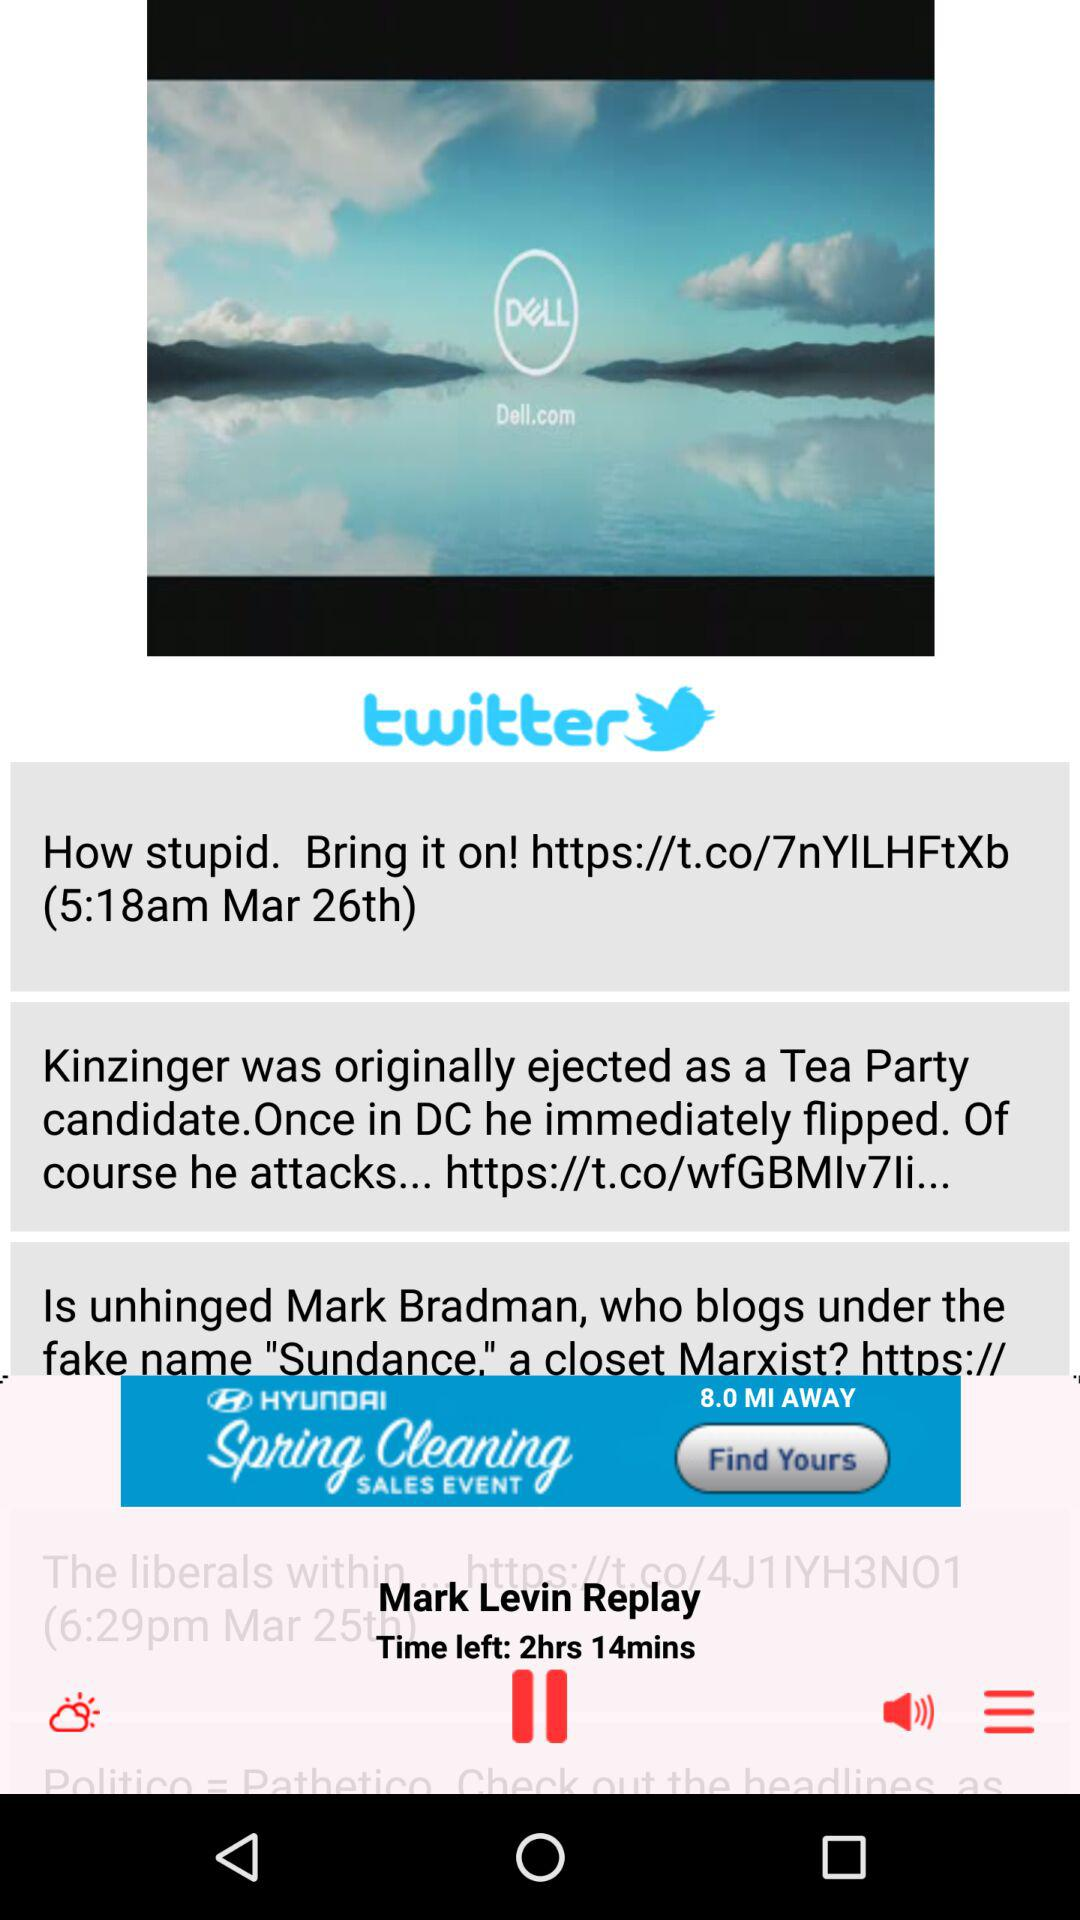What is the date? The dates are March 26th and March 25th. 